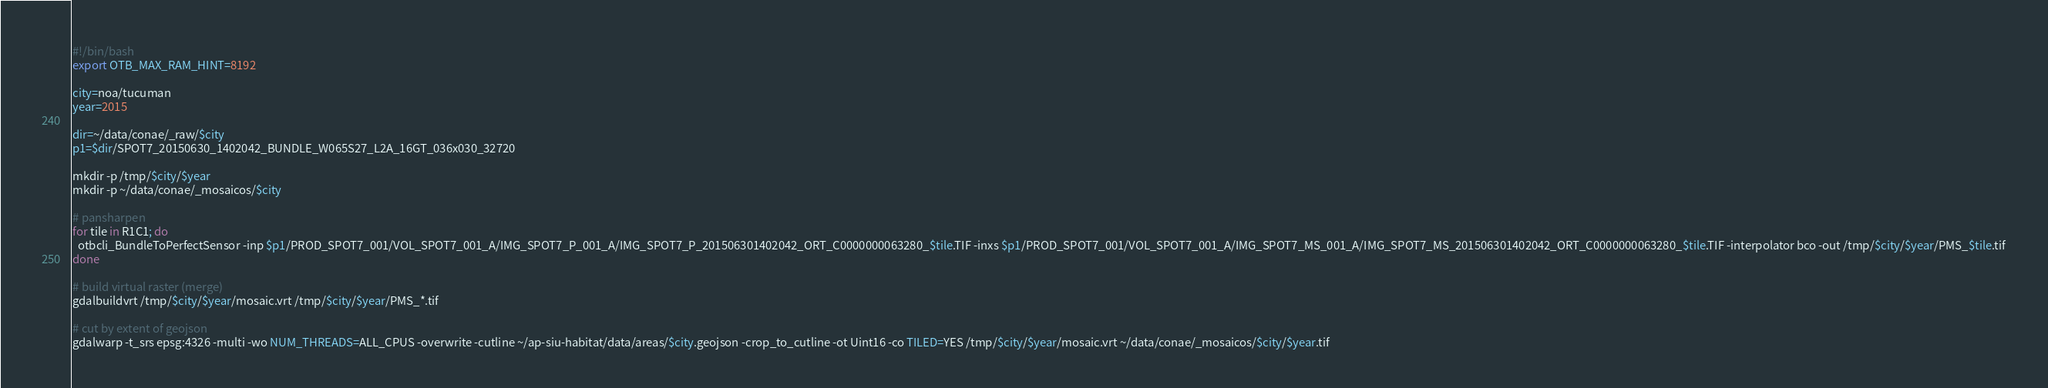<code> <loc_0><loc_0><loc_500><loc_500><_Bash_>#!/bin/bash
export OTB_MAX_RAM_HINT=8192

city=noa/tucuman
year=2015

dir=~/data/conae/_raw/$city
p1=$dir/SPOT7_20150630_1402042_BUNDLE_W065S27_L2A_16GT_036x030_32720

mkdir -p /tmp/$city/$year
mkdir -p ~/data/conae/_mosaicos/$city

# pansharpen
for tile in R1C1; do
  otbcli_BundleToPerfectSensor -inp $p1/PROD_SPOT7_001/VOL_SPOT7_001_A/IMG_SPOT7_P_001_A/IMG_SPOT7_P_201506301402042_ORT_C0000000063280_$tile.TIF -inxs $p1/PROD_SPOT7_001/VOL_SPOT7_001_A/IMG_SPOT7_MS_001_A/IMG_SPOT7_MS_201506301402042_ORT_C0000000063280_$tile.TIF -interpolator bco -out /tmp/$city/$year/PMS_$tile.tif
done

# build virtual raster (merge)
gdalbuildvrt /tmp/$city/$year/mosaic.vrt /tmp/$city/$year/PMS_*.tif

# cut by extent of geojson
gdalwarp -t_srs epsg:4326 -multi -wo NUM_THREADS=ALL_CPUS -overwrite -cutline ~/ap-siu-habitat/data/areas/$city.geojson -crop_to_cutline -ot Uint16 -co TILED=YES /tmp/$city/$year/mosaic.vrt ~/data/conae/_mosaicos/$city/$year.tif
</code> 